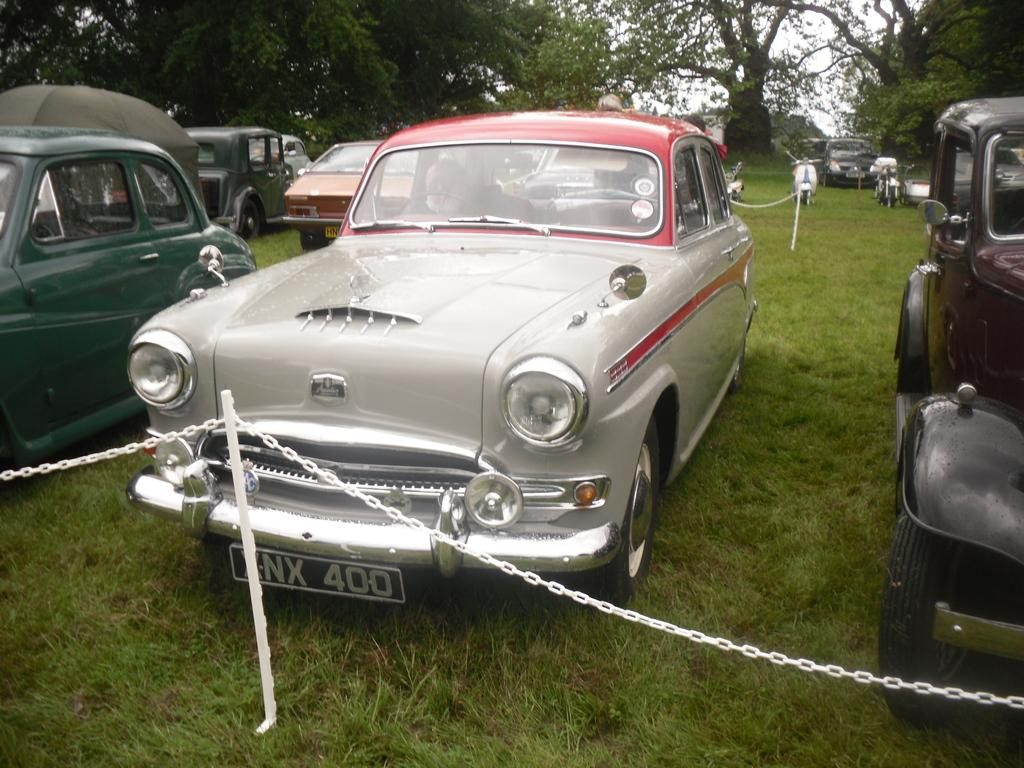What is the unusual location for the vehicles in the image? The vehicles are parked on the grass in the image. What objects are attached to the poles in the image? The poles have chains attached to them in the image. What type of vegetation can be seen at the top of the image? There are trees visible at the top of the image. Can you tell me how many parcels are being delivered by the snake in the image? There is no snake or parcel present in the image. What type of sun is visible in the image? There is no sun present in the image; only the sky is visible at the top of the image. 